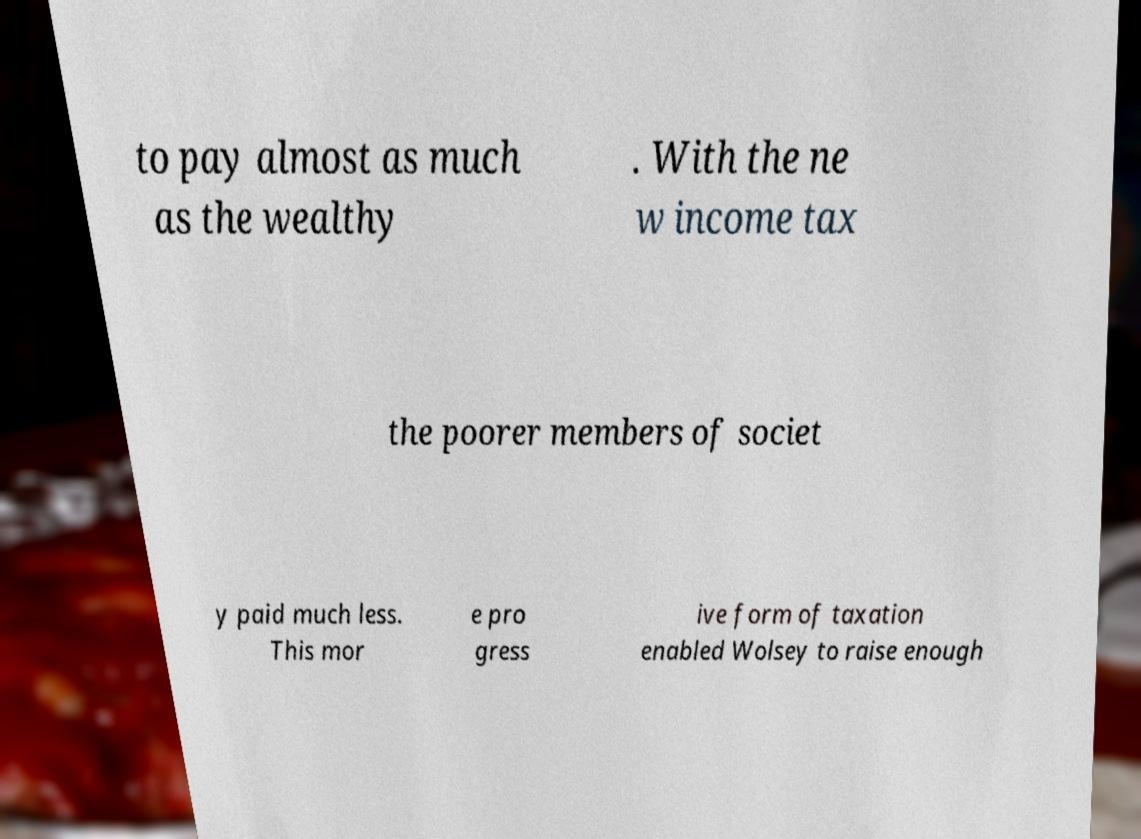What messages or text are displayed in this image? I need them in a readable, typed format. to pay almost as much as the wealthy . With the ne w income tax the poorer members of societ y paid much less. This mor e pro gress ive form of taxation enabled Wolsey to raise enough 